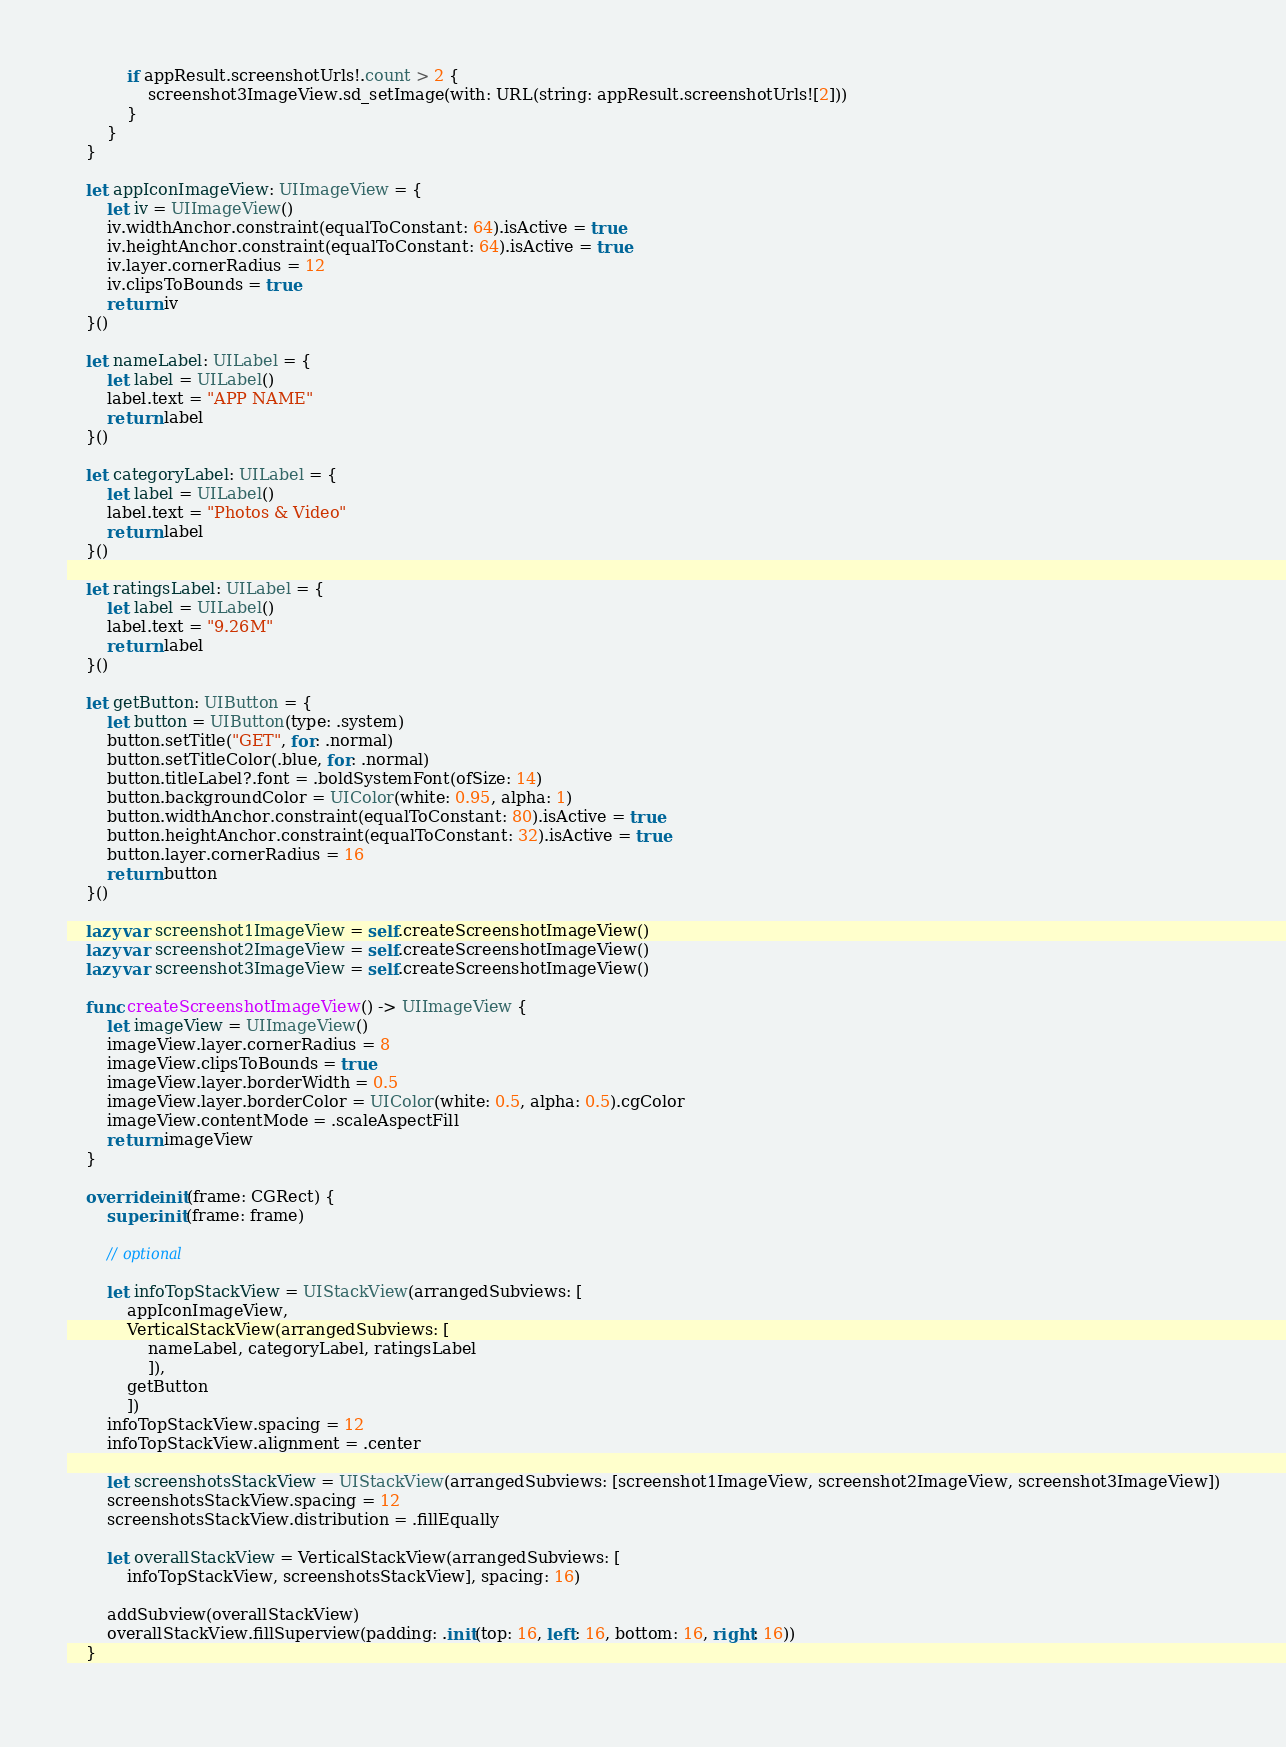<code> <loc_0><loc_0><loc_500><loc_500><_Swift_>            if appResult.screenshotUrls!.count > 2 {
                screenshot3ImageView.sd_setImage(with: URL(string: appResult.screenshotUrls![2]))
            }
        }
    }
    
    let appIconImageView: UIImageView = {
        let iv = UIImageView()
        iv.widthAnchor.constraint(equalToConstant: 64).isActive = true
        iv.heightAnchor.constraint(equalToConstant: 64).isActive = true
        iv.layer.cornerRadius = 12
        iv.clipsToBounds = true
        return iv
    }()
    
    let nameLabel: UILabel = {
        let label = UILabel()
        label.text = "APP NAME"
        return label
    }()
    
    let categoryLabel: UILabel = {
        let label = UILabel()
        label.text = "Photos & Video"
        return label
    }()
    
    let ratingsLabel: UILabel = {
        let label = UILabel()
        label.text = "9.26M"
        return label
    }()
    
    let getButton: UIButton = {
        let button = UIButton(type: .system)
        button.setTitle("GET", for: .normal)
        button.setTitleColor(.blue, for: .normal)
        button.titleLabel?.font = .boldSystemFont(ofSize: 14)
        button.backgroundColor = UIColor(white: 0.95, alpha: 1)
        button.widthAnchor.constraint(equalToConstant: 80).isActive = true
        button.heightAnchor.constraint(equalToConstant: 32).isActive = true
        button.layer.cornerRadius = 16
        return button
    }()
    
    lazy var screenshot1ImageView = self.createScreenshotImageView()
    lazy var screenshot2ImageView = self.createScreenshotImageView()
    lazy var screenshot3ImageView = self.createScreenshotImageView()
    
    func createScreenshotImageView() -> UIImageView {
        let imageView = UIImageView()
        imageView.layer.cornerRadius = 8
        imageView.clipsToBounds = true
        imageView.layer.borderWidth = 0.5
        imageView.layer.borderColor = UIColor(white: 0.5, alpha: 0.5).cgColor
        imageView.contentMode = .scaleAspectFill
        return imageView
    }
    
    override init(frame: CGRect) {
        super.init(frame: frame)
        
        // optional
        
        let infoTopStackView = UIStackView(arrangedSubviews: [
            appIconImageView,
            VerticalStackView(arrangedSubviews: [
                nameLabel, categoryLabel, ratingsLabel
                ]),
            getButton
            ])
        infoTopStackView.spacing = 12
        infoTopStackView.alignment = .center
        
        let screenshotsStackView = UIStackView(arrangedSubviews: [screenshot1ImageView, screenshot2ImageView, screenshot3ImageView])
        screenshotsStackView.spacing = 12
        screenshotsStackView.distribution = .fillEqually
        
        let overallStackView = VerticalStackView(arrangedSubviews: [
            infoTopStackView, screenshotsStackView], spacing: 16)
        
        addSubview(overallStackView)
        overallStackView.fillSuperview(padding: .init(top: 16, left: 16, bottom: 16, right: 16))
    }
    </code> 